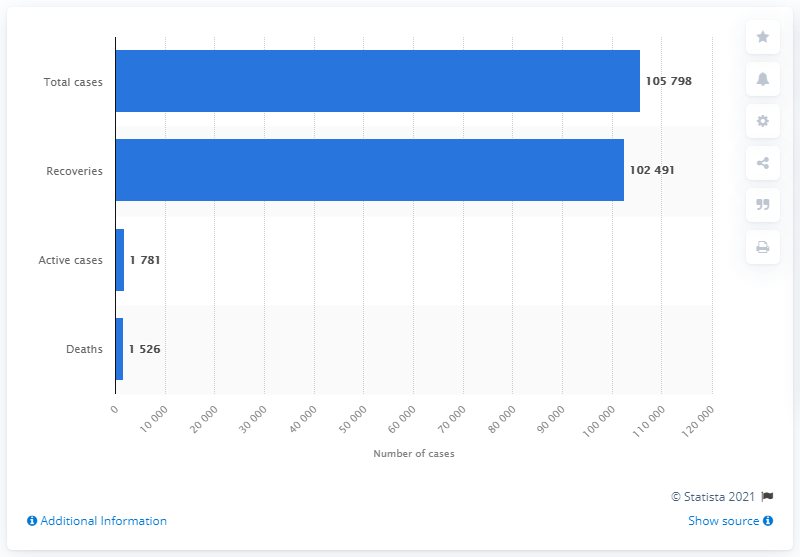Indicate a few pertinent items in this graphic. As of January 2023, a total of 1,024,913 COVID-19 patients have recovered worldwide. As of June 20, 2021, there were 10,5798 confirmed cases of COVID-19 in Quezon City. 